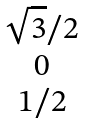<formula> <loc_0><loc_0><loc_500><loc_500>\begin{matrix} \sqrt { 3 } / 2 \\ 0 \\ 1 / 2 \end{matrix}</formula> 